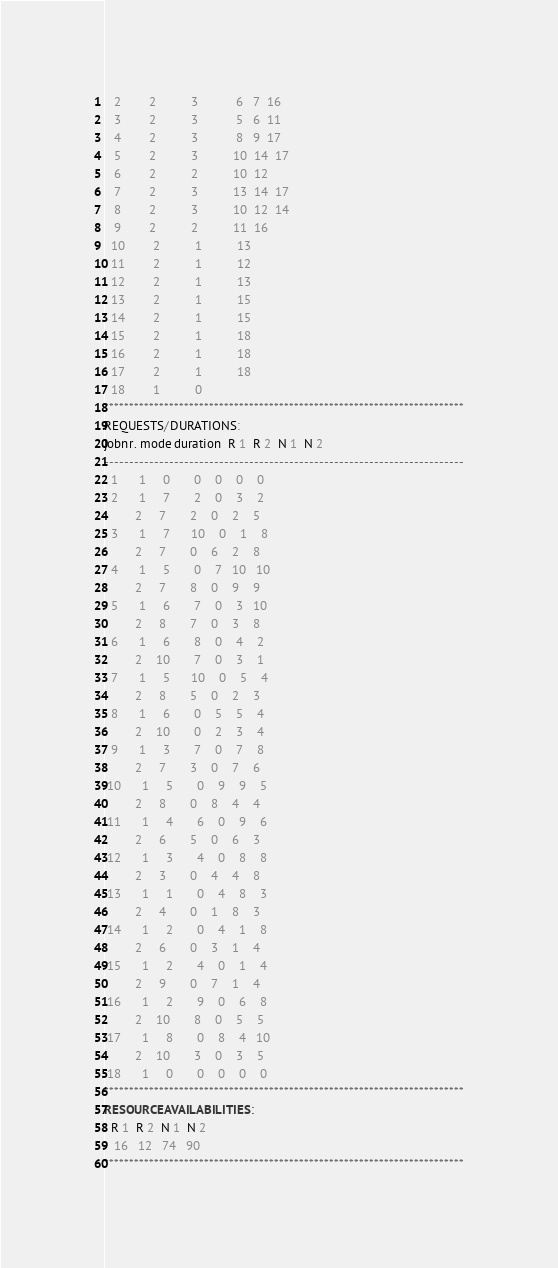<code> <loc_0><loc_0><loc_500><loc_500><_ObjectiveC_>   2        2          3           6   7  16
   3        2          3           5   6  11
   4        2          3           8   9  17
   5        2          3          10  14  17
   6        2          2          10  12
   7        2          3          13  14  17
   8        2          3          10  12  14
   9        2          2          11  16
  10        2          1          13
  11        2          1          12
  12        2          1          13
  13        2          1          15
  14        2          1          15
  15        2          1          18
  16        2          1          18
  17        2          1          18
  18        1          0        
************************************************************************
REQUESTS/DURATIONS:
jobnr. mode duration  R 1  R 2  N 1  N 2
------------------------------------------------------------------------
  1      1     0       0    0    0    0
  2      1     7       2    0    3    2
         2     7       2    0    2    5
  3      1     7      10    0    1    8
         2     7       0    6    2    8
  4      1     5       0    7   10   10
         2     7       8    0    9    9
  5      1     6       7    0    3   10
         2     8       7    0    3    8
  6      1     6       8    0    4    2
         2    10       7    0    3    1
  7      1     5      10    0    5    4
         2     8       5    0    2    3
  8      1     6       0    5    5    4
         2    10       0    2    3    4
  9      1     3       7    0    7    8
         2     7       3    0    7    6
 10      1     5       0    9    9    5
         2     8       0    8    4    4
 11      1     4       6    0    9    6
         2     6       5    0    6    3
 12      1     3       4    0    8    8
         2     3       0    4    4    8
 13      1     1       0    4    8    3
         2     4       0    1    8    3
 14      1     2       0    4    1    8
         2     6       0    3    1    4
 15      1     2       4    0    1    4
         2     9       0    7    1    4
 16      1     2       9    0    6    8
         2    10       8    0    5    5
 17      1     8       0    8    4   10
         2    10       3    0    3    5
 18      1     0       0    0    0    0
************************************************************************
RESOURCEAVAILABILITIES:
  R 1  R 2  N 1  N 2
   16   12   74   90
************************************************************************
</code> 